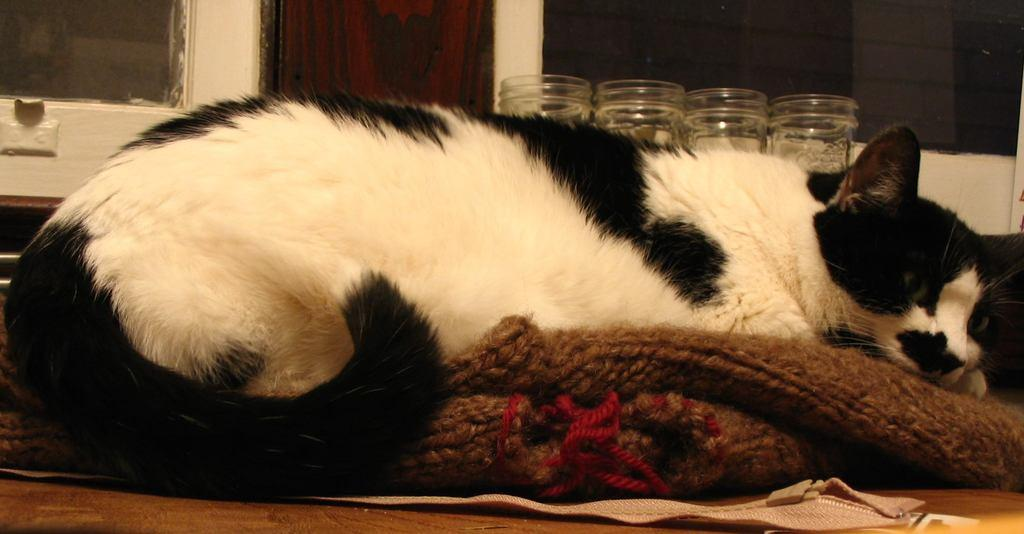What type of animal is in the image? There is a cat in the image. What is the cat lying on? The cat is lying on a cloth. What can be seen in the background of the image? There are glass objects in the background of the image. What is the cat's reaction to the increase in income in the image? There is no mention of income or any reaction in the image; it simply shows a cat lying on a cloth with glass objects in the background. 